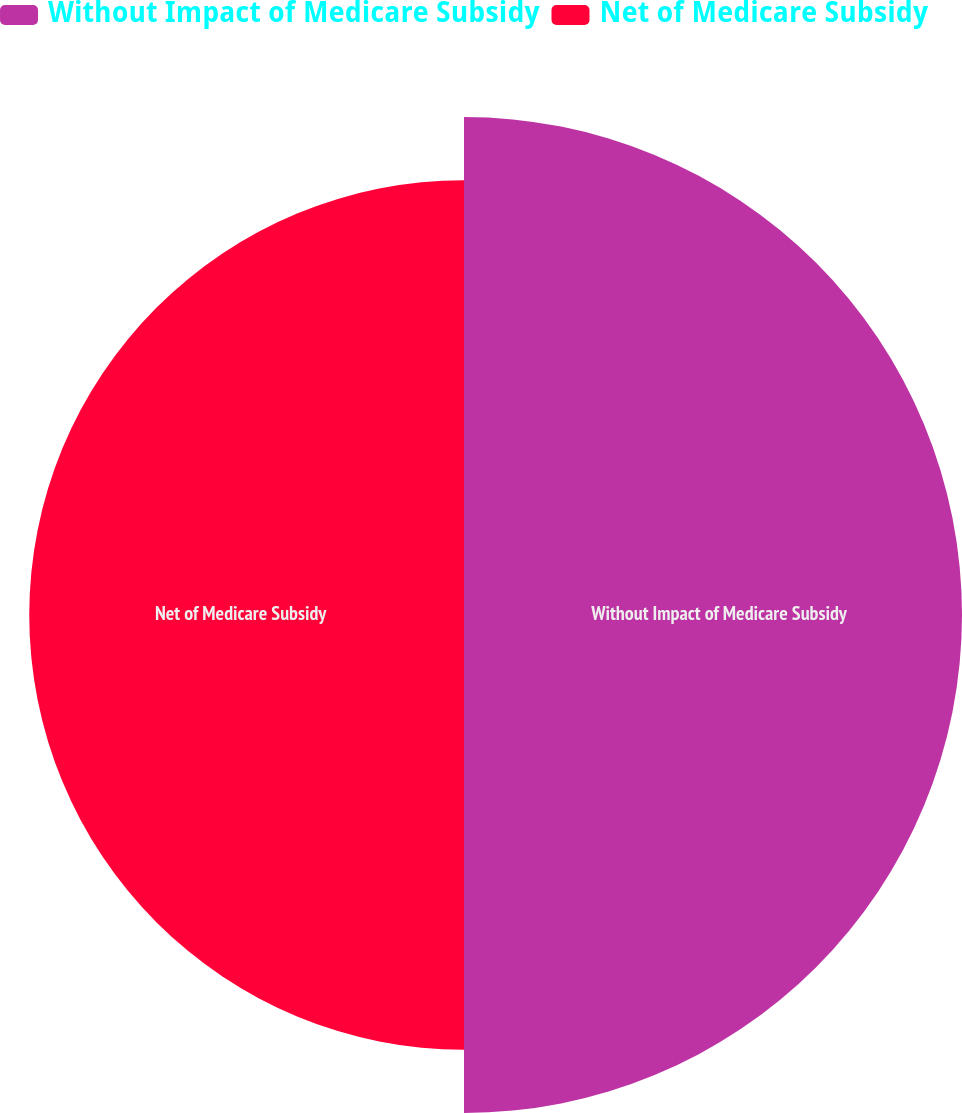<chart> <loc_0><loc_0><loc_500><loc_500><pie_chart><fcel>Without Impact of Medicare Subsidy<fcel>Net of Medicare Subsidy<nl><fcel>53.39%<fcel>46.61%<nl></chart> 